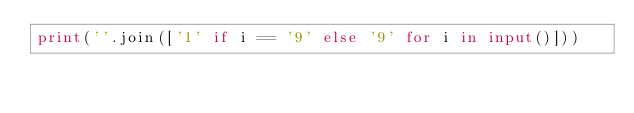Convert code to text. <code><loc_0><loc_0><loc_500><loc_500><_Python_>print(''.join(['1' if i == '9' else '9' for i in input()]))</code> 